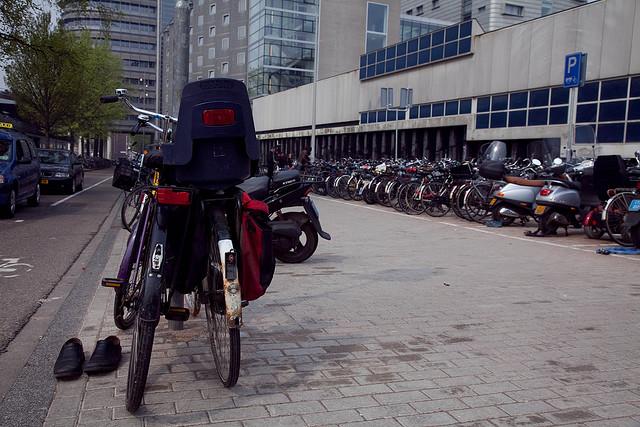Are the shoes tennis shoes?
Concise answer only. No. What does the blue 'P' on the sign mean?
Answer briefly. Parking. Where is the bike lane in the photograph?
Give a very brief answer. Left. 